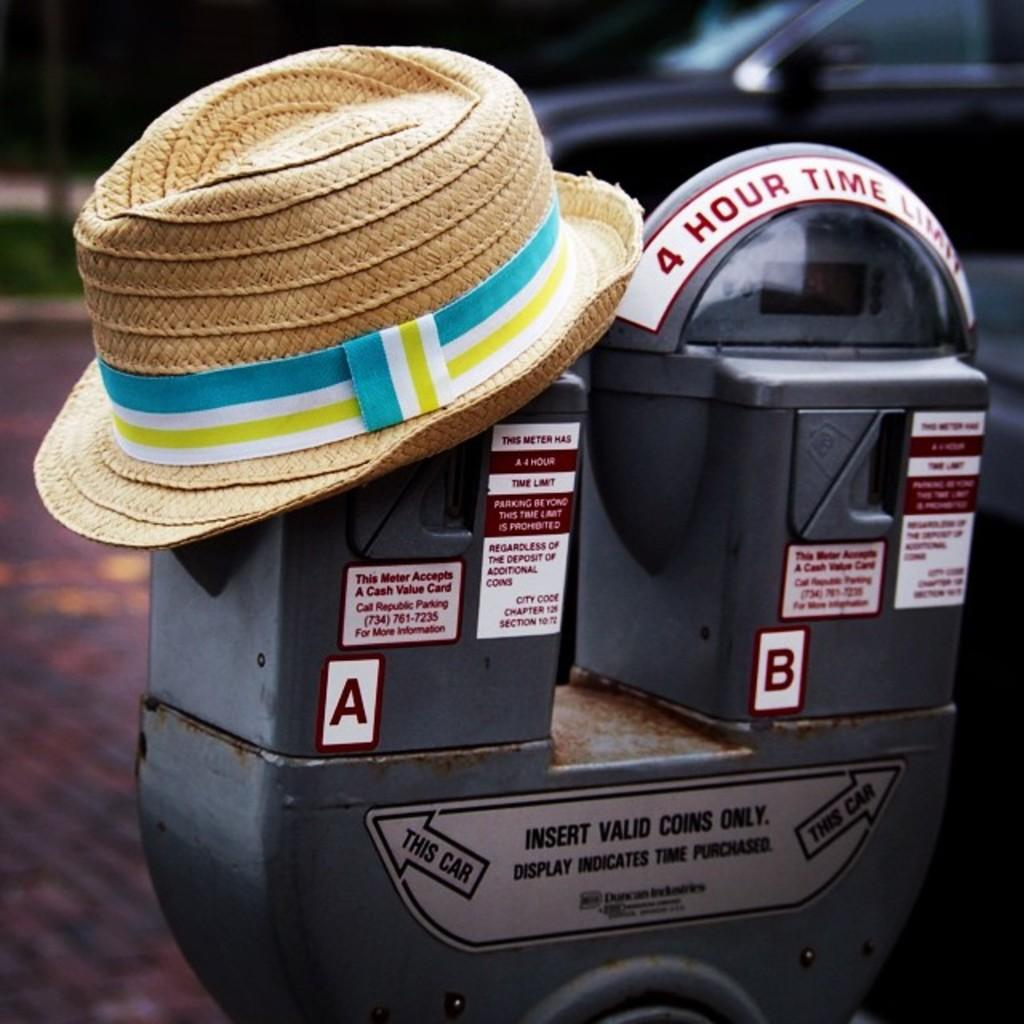<image>
Create a compact narrative representing the image presented. the letter B is on the parking meter next to another one 